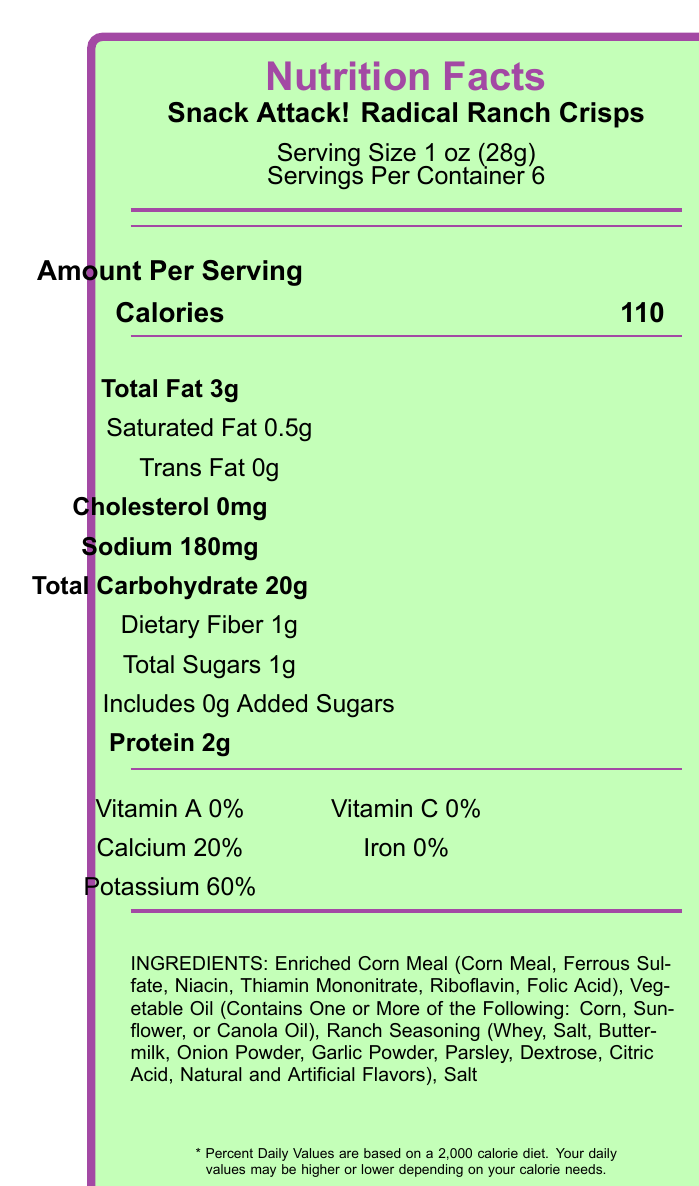What is the serving size of "Snack Attack! Radical Ranch Crisps"? The serving size is clearly stated under the product name and nutrition facts heading.
Answer: 1 oz (28g) How many calories are in one serving? The calories per serving is listed right next to the "Calories" label under the Nutrition Facts.
Answer: 110 What is the total fat content per serving in grams? The total fat content per serving is explicitly mentioned as "Total Fat 3g" within the nutritional information.
Answer: 3g How much sodium is there per serving? The sodium content per serving is listed clearly as "Sodium 180mg".
Answer: 180mg What are the first three ingredients listed? The first three ingredients listed are "Enriched Corn Meal", "Vegetable Oil", and "Ranch Seasoning".
Answer: Enriched Corn Meal, Vegetable Oil, Ranch Seasoning Which of the following vitamins and minerals are present in the product? A. Vitamin D B. Calcium C. Iron D. Potassium The nutritional section lists "Calcium 20%" and "Potassium 60%" indicating their presence, whereas Vitamin D and Iron are not listed or have 0%.
Answer: B and D How many grams of protein are in each serving? A. 1g B. 2g C. 3g D. 0g The document indicates that each serving contains "Protein 2g".
Answer: B. 2g Does this product contain any cholesterol? The nutritional information states "Cholesterol 0mg", indicating there is no cholesterol.
Answer: No Is there any trans fat included in "Snack Attack! Radical Ranch Crisps"? The document shows "Trans Fat 0g", meaning there is no trans fat.
Answer: No Describe the packaging and visual recommendations provided for filming. The packaging details and filming recommendations are given in the background section under "packaging_description" and "cinematic_notes".
Answer: The packaging is described as a neon green bag with bold purple lightning bolts and radical 90s-style typography. For filming, it is suggested to use high-contrast lighting, consider a fisheye lens for close-ups, and use vibrant neon backlighting to capture the 90s aesthetic. What is the total carbohydrate amount in grams per serving? The nutritional information lists "Total Carbohydrate 20g".
Answer: 20g Can the presence of any artificial flavors be determined? The ingredient list includes "Natural and Artificial Flavors" under Ranch Seasoning, indicating the presence of artificial flavors.
Answer: Yes What flavors are predominantly used in the ranch seasoning? These are the specific ingredients mentioned in "Ranch Seasoning" according to the document.
Answer: Whey, Salt, Buttermilk, Onion Powder, Garlic Powder, Parsley, Dextrose, Citric Acid, Natural and Artificial Flavors What is the percentage of Potassium in the product? The document indicates that the product contains "Potassium 60%".
Answer: 60% Is there any information about the brand history or founding year of "Snack Attack!"? The document does not provide any information regarding the brand history or founding year of "Snack Attack!".
Answer: Cannot be determined 